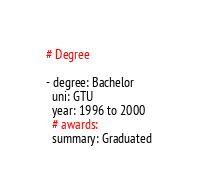Convert code to text. <code><loc_0><loc_0><loc_500><loc_500><_YAML_># Degree

- degree: Bachelor 
  uni: GTU
  year: 1996 to 2000
  # awards:
  summary: Graduated


</code> 